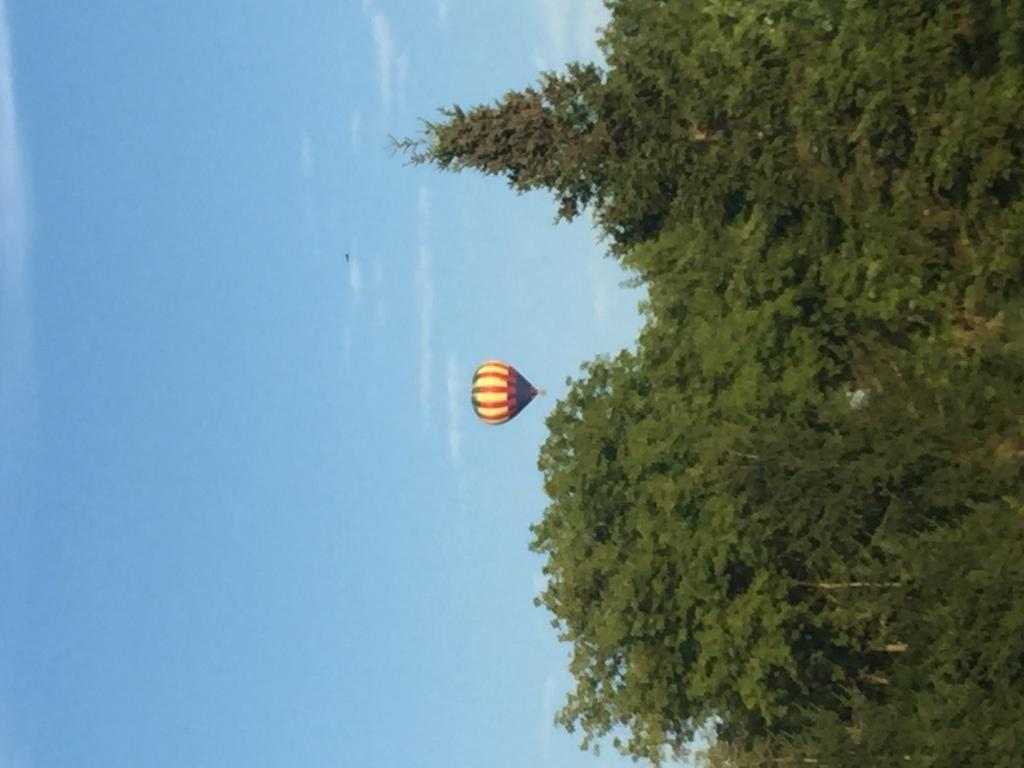What type of vegetation can be seen in the image? There are trees in the image. What is the main object in the sky in the image? There is an air balloon in the image. What is visible in the background of the image? The sky is visible in the image. What can be seen in the sky besides the air balloon? Clouds are present in the image. What type of class is being held in the image? There is no class present in the image. Is there a cellar visible in the image? There is no cellar present in the image. 